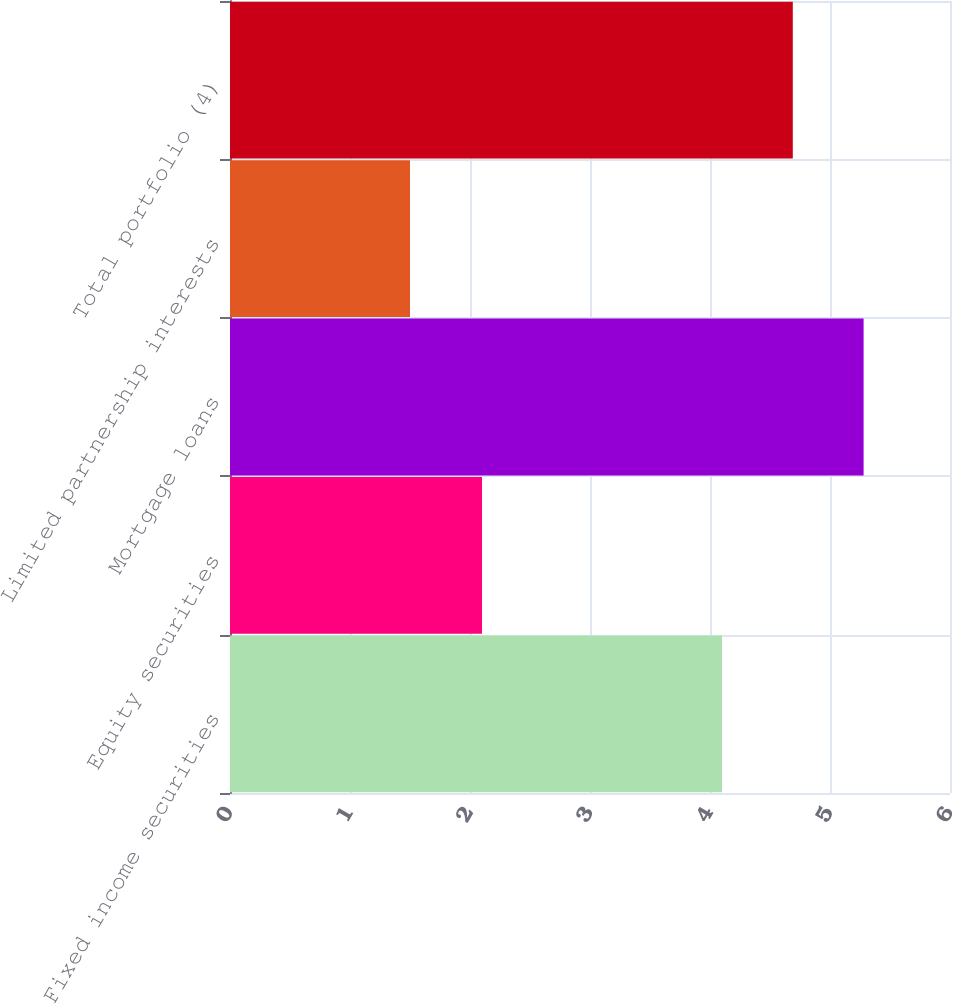<chart> <loc_0><loc_0><loc_500><loc_500><bar_chart><fcel>Fixed income securities<fcel>Equity securities<fcel>Mortgage loans<fcel>Limited partnership interests<fcel>Total portfolio (4)<nl><fcel>4.1<fcel>2.1<fcel>5.28<fcel>1.5<fcel>4.69<nl></chart> 